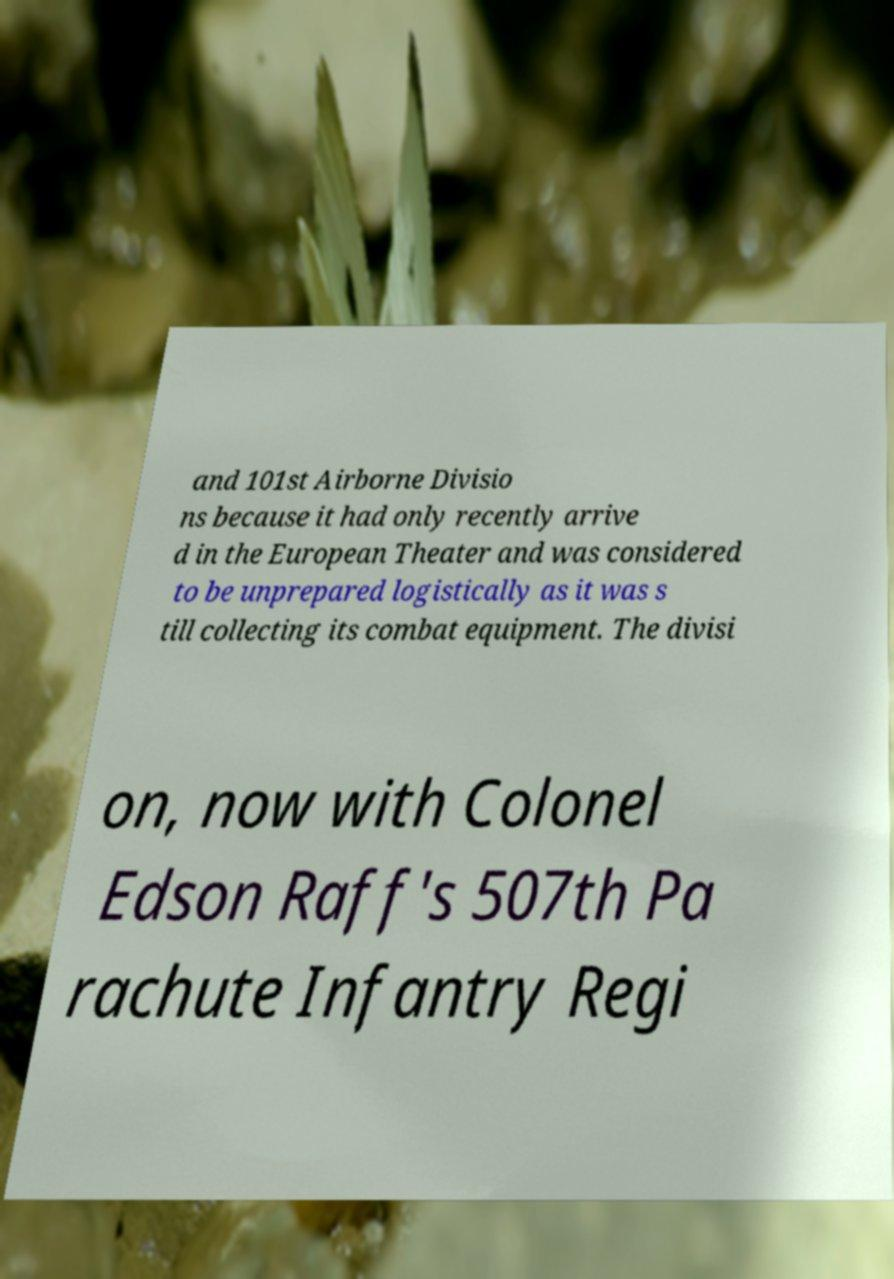What messages or text are displayed in this image? I need them in a readable, typed format. and 101st Airborne Divisio ns because it had only recently arrive d in the European Theater and was considered to be unprepared logistically as it was s till collecting its combat equipment. The divisi on, now with Colonel Edson Raff's 507th Pa rachute Infantry Regi 